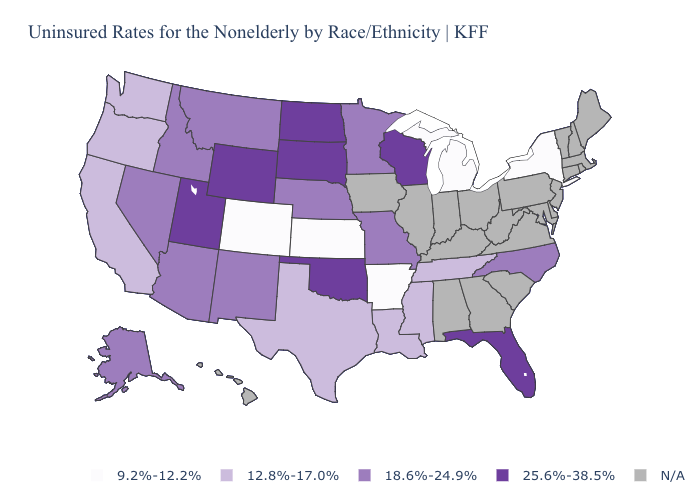What is the highest value in the USA?
Give a very brief answer. 25.6%-38.5%. Name the states that have a value in the range 12.8%-17.0%?
Short answer required. California, Louisiana, Mississippi, Oregon, Tennessee, Texas, Washington. What is the value of Nebraska?
Give a very brief answer. 18.6%-24.9%. What is the lowest value in states that border New Mexico?
Give a very brief answer. 9.2%-12.2%. Name the states that have a value in the range 25.6%-38.5%?
Answer briefly. Florida, North Dakota, Oklahoma, South Dakota, Utah, Wisconsin, Wyoming. What is the value of Colorado?
Keep it brief. 9.2%-12.2%. Does North Dakota have the highest value in the USA?
Short answer required. Yes. Name the states that have a value in the range N/A?
Give a very brief answer. Alabama, Connecticut, Delaware, Georgia, Hawaii, Illinois, Indiana, Iowa, Kentucky, Maine, Maryland, Massachusetts, New Hampshire, New Jersey, Ohio, Pennsylvania, Rhode Island, South Carolina, Vermont, Virginia, West Virginia. Name the states that have a value in the range 12.8%-17.0%?
Be succinct. California, Louisiana, Mississippi, Oregon, Tennessee, Texas, Washington. Name the states that have a value in the range 18.6%-24.9%?
Keep it brief. Alaska, Arizona, Idaho, Minnesota, Missouri, Montana, Nebraska, Nevada, New Mexico, North Carolina. What is the highest value in states that border Montana?
Be succinct. 25.6%-38.5%. What is the value of Maryland?
Answer briefly. N/A. Does the map have missing data?
Short answer required. Yes. 